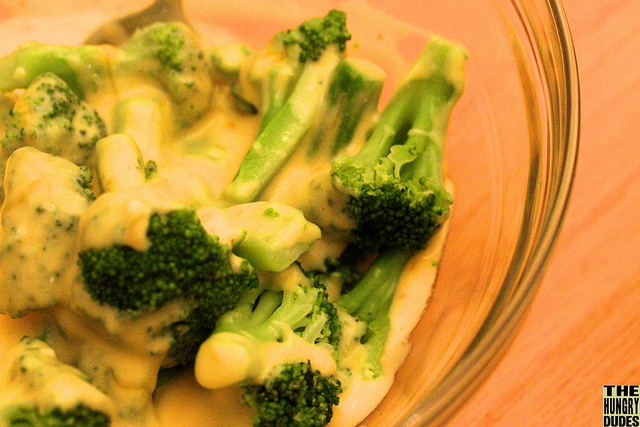Describe the objects in this image and their specific colors. I can see bowl in orange, gold, and olive tones, broccoli in orange, olive, and black tones, broccoli in orange, gold, and olive tones, broccoli in orange, black, gold, and darkgreen tones, and broccoli in orange, olive, gold, and black tones in this image. 